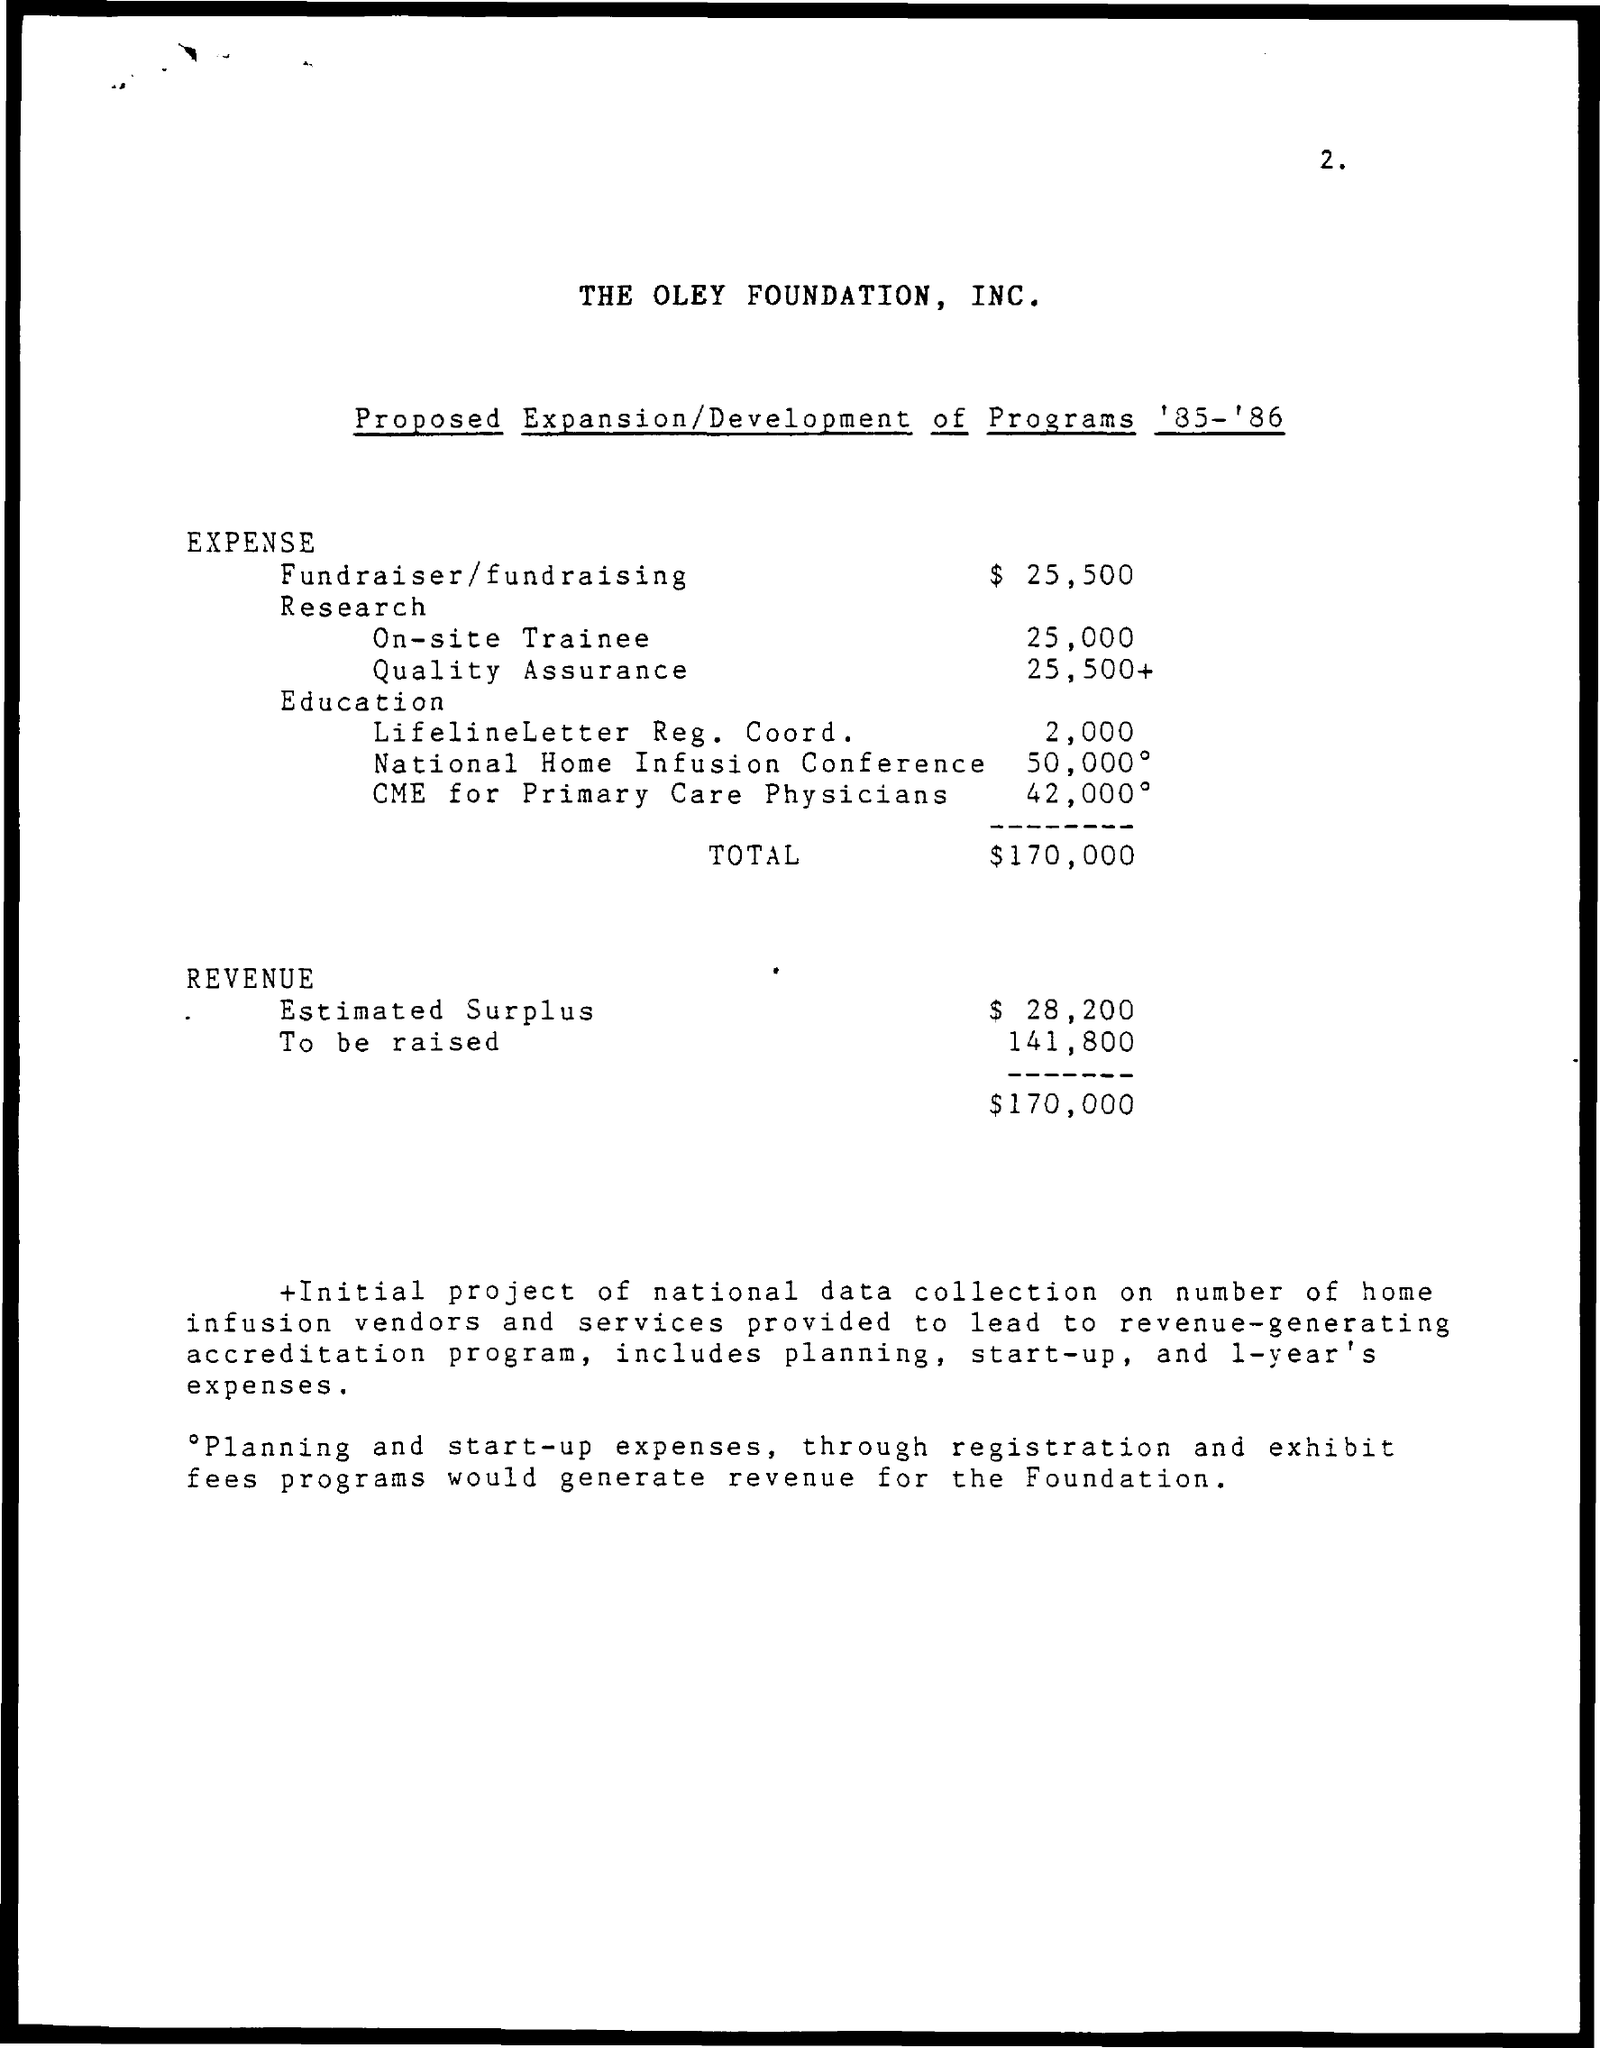Point out several critical features in this image. The name of the Foundation is The Oley Foundation, Inc. 